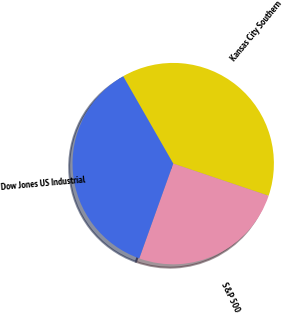Convert chart. <chart><loc_0><loc_0><loc_500><loc_500><pie_chart><fcel>Kansas City Southern<fcel>S&P 500<fcel>Dow Jones US Industrial<nl><fcel>38.47%<fcel>25.29%<fcel>36.24%<nl></chart> 